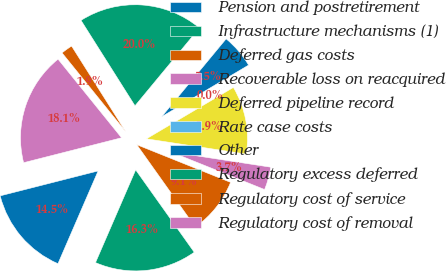Convert chart. <chart><loc_0><loc_0><loc_500><loc_500><pie_chart><fcel>Pension and postretirement<fcel>Infrastructure mechanisms (1)<fcel>Deferred gas costs<fcel>Recoverable loss on reacquired<fcel>Deferred pipeline record<fcel>Rate case costs<fcel>Other<fcel>Regulatory excess deferred<fcel>Regulatory cost of service<fcel>Regulatory cost of removal<nl><fcel>14.53%<fcel>16.34%<fcel>9.09%<fcel>3.66%<fcel>10.91%<fcel>0.03%<fcel>5.47%<fcel>19.97%<fcel>1.85%<fcel>18.15%<nl></chart> 